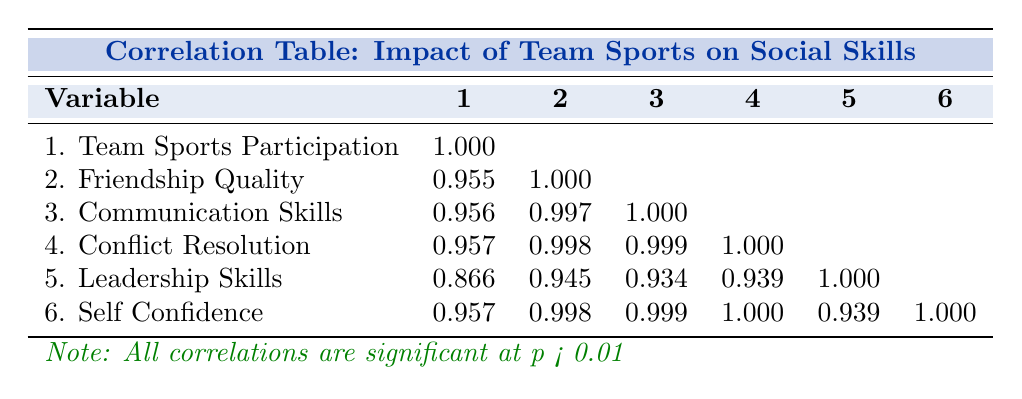What's the correlation between Team Sports Participation and Friendship Quality? Referring to the table, the correlation value between Team Sports Participation (1) and Friendship Quality (2) is 0.955.
Answer: 0.955 What is the highest correlation value shown in the table? By examining the table closely, the highest correlation value is 0.999 between Communication Skills (3) and Conflict Resolution Skills (4).
Answer: 0.999 Is there a positive correlation between Team Sports Participation and Leadership Skills? Looking at the correlation values, the correlation between Team Sports Participation (1) and Leadership Skills (5) is 0.866, which indicates a positive correlation.
Answer: Yes What correlation value would you expect between Friendship Quality and Self Confidence? Based on the table, the correlation value between Friendship Quality (2) and Self Confidence (6) is 0.998, suggesting a strong positive relationship.
Answer: 0.998 What is the average correlation value involving Team Sports Participation? To find the average correlation involving Team Sports Participation, we will take the mean of its correlation values with the other variables: (1.000 + 0.955 + 0.956 + 0.957 + 0.866 + 0.957) / 5 = 0.9382.
Answer: 0.9382 How many variables have a correlation of 1.000 with Conflict Resolution Skills? Checking the table, Conflict Resolution Skills (4) has a correlation of 1.000 with itself and 0.999 with Communication Skills (3) and 0.957 with Self Confidence (6), but only correlates fully with itself. Therefore, the count is one.
Answer: One Does increased Team Sports Participation lead to better Communication Skills, according to the given data? The correlation value between Team Sports Participation (1) and Communication Skills (3) is 0.956, indicating a strong positive relationship, hence suggesting that increased participation leads to better skills.
Answer: Yes Which skill shows the weakest correlation with Team Sports Participation? Based on the table, Leadership Skills (5) has the weakest correlation with Team Sports Participation (1) at 0.866 among the comparisons.
Answer: 0.866 